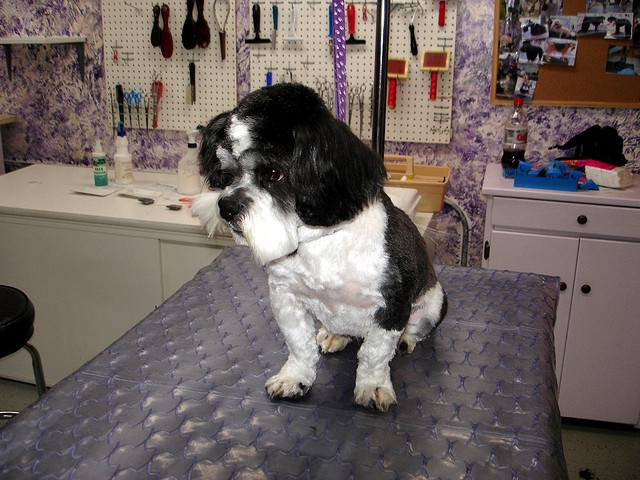Describe the objects in this image and their specific colors. I can see dining table in gray and black tones, dog in gray, black, lightgray, and darkgray tones, chair in gray, black, and maroon tones, bottle in gray, black, and maroon tones, and bottle in gray, tan, and black tones in this image. 